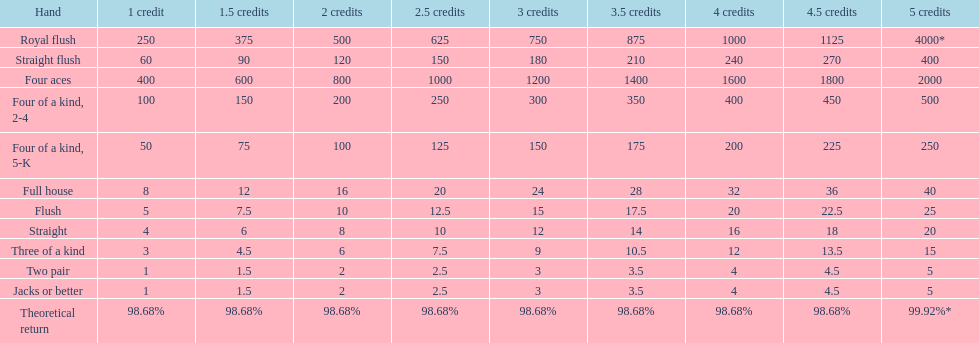How many credits do you have to spend to get at least 2000 in payout if you had four aces? 5 credits. 